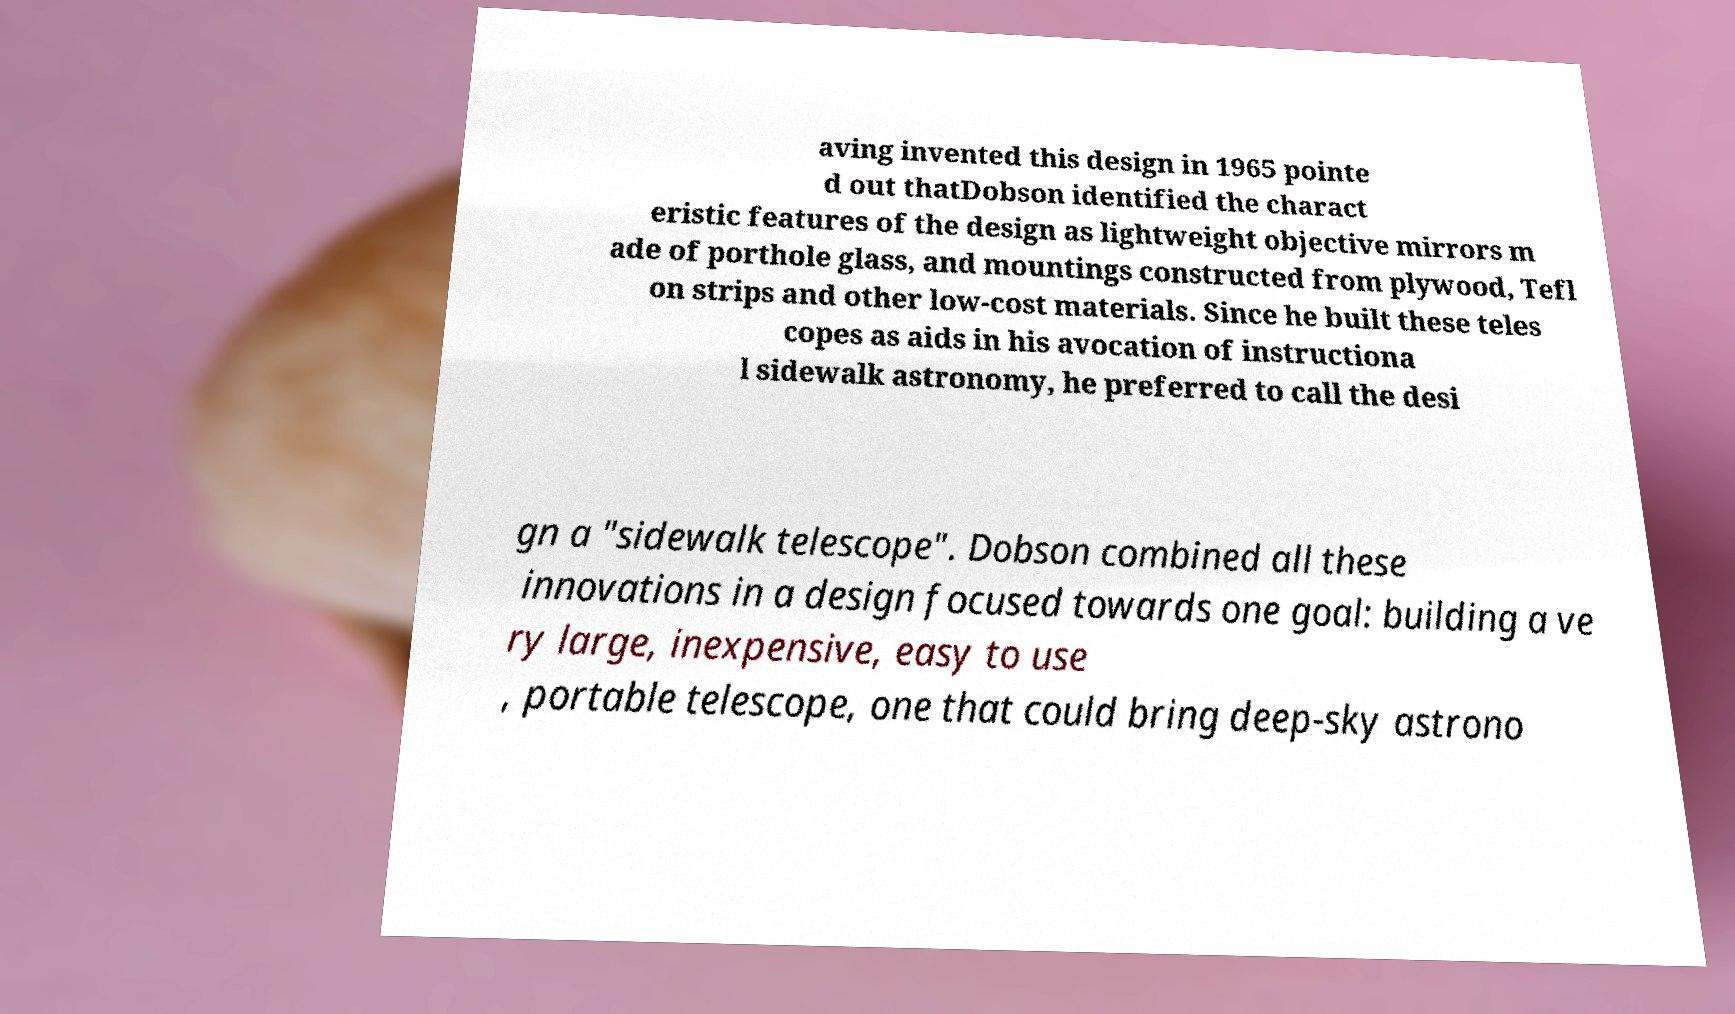Please read and relay the text visible in this image. What does it say? aving invented this design in 1965 pointe d out thatDobson identified the charact eristic features of the design as lightweight objective mirrors m ade of porthole glass, and mountings constructed from plywood, Tefl on strips and other low-cost materials. Since he built these teles copes as aids in his avocation of instructiona l sidewalk astronomy, he preferred to call the desi gn a "sidewalk telescope". Dobson combined all these innovations in a design focused towards one goal: building a ve ry large, inexpensive, easy to use , portable telescope, one that could bring deep-sky astrono 